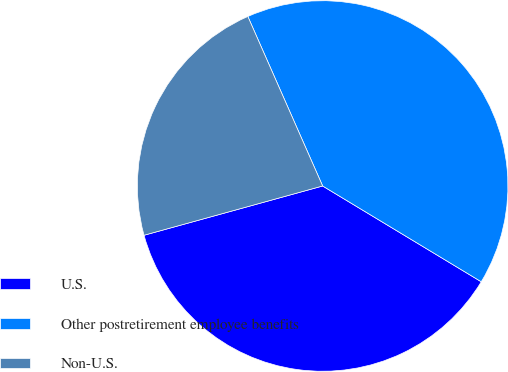Convert chart to OTSL. <chart><loc_0><loc_0><loc_500><loc_500><pie_chart><fcel>U.S.<fcel>Other postretirement employee benefits<fcel>Non-U.S.<nl><fcel>37.07%<fcel>40.26%<fcel>22.67%<nl></chart> 